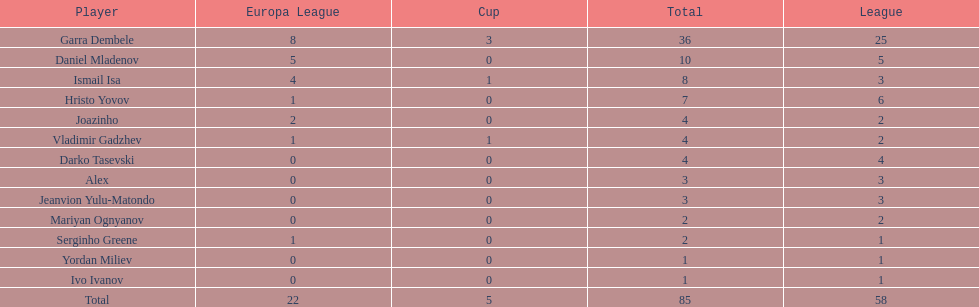How many goals did ismail isa score this season? 8. 